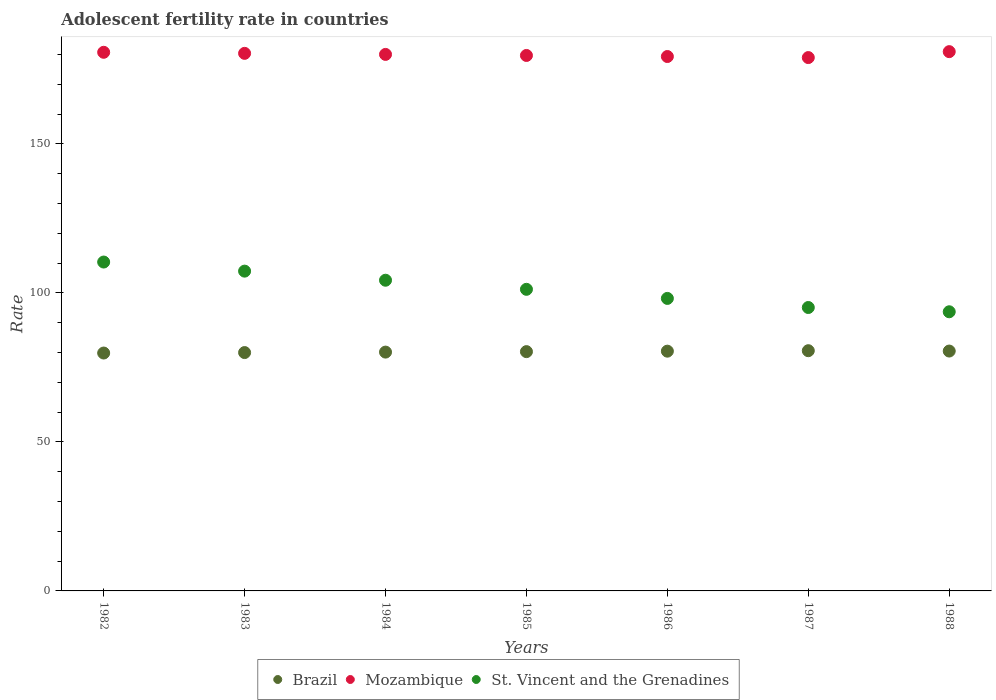How many different coloured dotlines are there?
Offer a terse response. 3. Is the number of dotlines equal to the number of legend labels?
Provide a succinct answer. Yes. What is the adolescent fertility rate in Brazil in 1987?
Your response must be concise. 80.61. Across all years, what is the maximum adolescent fertility rate in Mozambique?
Your answer should be very brief. 180.97. Across all years, what is the minimum adolescent fertility rate in Mozambique?
Your answer should be compact. 178.98. In which year was the adolescent fertility rate in Mozambique maximum?
Ensure brevity in your answer.  1988. What is the total adolescent fertility rate in St. Vincent and the Grenadines in the graph?
Ensure brevity in your answer.  710.1. What is the difference between the adolescent fertility rate in Brazil in 1984 and that in 1987?
Your answer should be compact. -0.47. What is the difference between the adolescent fertility rate in St. Vincent and the Grenadines in 1983 and the adolescent fertility rate in Mozambique in 1982?
Your answer should be compact. -73.44. What is the average adolescent fertility rate in St. Vincent and the Grenadines per year?
Ensure brevity in your answer.  101.44. In the year 1982, what is the difference between the adolescent fertility rate in Mozambique and adolescent fertility rate in Brazil?
Make the answer very short. 100.92. What is the ratio of the adolescent fertility rate in Brazil in 1984 to that in 1988?
Your response must be concise. 1. Is the adolescent fertility rate in St. Vincent and the Grenadines in 1982 less than that in 1987?
Offer a very short reply. No. What is the difference between the highest and the second highest adolescent fertility rate in Brazil?
Your response must be concise. 0.12. What is the difference between the highest and the lowest adolescent fertility rate in St. Vincent and the Grenadines?
Provide a short and direct response. 16.69. In how many years, is the adolescent fertility rate in Brazil greater than the average adolescent fertility rate in Brazil taken over all years?
Offer a terse response. 4. Is it the case that in every year, the sum of the adolescent fertility rate in Brazil and adolescent fertility rate in Mozambique  is greater than the adolescent fertility rate in St. Vincent and the Grenadines?
Provide a succinct answer. Yes. Does the adolescent fertility rate in Mozambique monotonically increase over the years?
Provide a short and direct response. No. Is the adolescent fertility rate in Mozambique strictly less than the adolescent fertility rate in Brazil over the years?
Provide a short and direct response. No. Does the graph contain grids?
Keep it short and to the point. No. How many legend labels are there?
Offer a very short reply. 3. How are the legend labels stacked?
Give a very brief answer. Horizontal. What is the title of the graph?
Provide a short and direct response. Adolescent fertility rate in countries. Does "Maldives" appear as one of the legend labels in the graph?
Ensure brevity in your answer.  No. What is the label or title of the X-axis?
Your answer should be very brief. Years. What is the label or title of the Y-axis?
Your response must be concise. Rate. What is the Rate of Brazil in 1982?
Make the answer very short. 79.83. What is the Rate of Mozambique in 1982?
Keep it short and to the point. 180.75. What is the Rate in St. Vincent and the Grenadines in 1982?
Your response must be concise. 110.36. What is the Rate of Brazil in 1983?
Your answer should be very brief. 79.99. What is the Rate in Mozambique in 1983?
Provide a succinct answer. 180.4. What is the Rate of St. Vincent and the Grenadines in 1983?
Provide a succinct answer. 107.31. What is the Rate in Brazil in 1984?
Keep it short and to the point. 80.14. What is the Rate of Mozambique in 1984?
Ensure brevity in your answer.  180.04. What is the Rate in St. Vincent and the Grenadines in 1984?
Your response must be concise. 104.26. What is the Rate in Brazil in 1985?
Give a very brief answer. 80.3. What is the Rate of Mozambique in 1985?
Give a very brief answer. 179.69. What is the Rate of St. Vincent and the Grenadines in 1985?
Your answer should be compact. 101.21. What is the Rate of Brazil in 1986?
Keep it short and to the point. 80.46. What is the Rate in Mozambique in 1986?
Offer a very short reply. 179.33. What is the Rate of St. Vincent and the Grenadines in 1986?
Provide a short and direct response. 98.16. What is the Rate in Brazil in 1987?
Keep it short and to the point. 80.61. What is the Rate of Mozambique in 1987?
Provide a succinct answer. 178.98. What is the Rate of St. Vincent and the Grenadines in 1987?
Provide a short and direct response. 95.11. What is the Rate of Brazil in 1988?
Your response must be concise. 80.5. What is the Rate in Mozambique in 1988?
Offer a terse response. 180.97. What is the Rate of St. Vincent and the Grenadines in 1988?
Keep it short and to the point. 93.68. Across all years, what is the maximum Rate in Brazil?
Provide a short and direct response. 80.61. Across all years, what is the maximum Rate in Mozambique?
Offer a terse response. 180.97. Across all years, what is the maximum Rate in St. Vincent and the Grenadines?
Ensure brevity in your answer.  110.36. Across all years, what is the minimum Rate in Brazil?
Your answer should be very brief. 79.83. Across all years, what is the minimum Rate of Mozambique?
Make the answer very short. 178.98. Across all years, what is the minimum Rate of St. Vincent and the Grenadines?
Make the answer very short. 93.68. What is the total Rate of Brazil in the graph?
Provide a short and direct response. 561.82. What is the total Rate in Mozambique in the graph?
Provide a short and direct response. 1260.16. What is the total Rate of St. Vincent and the Grenadines in the graph?
Provide a short and direct response. 710.1. What is the difference between the Rate in Brazil in 1982 and that in 1983?
Keep it short and to the point. -0.16. What is the difference between the Rate of Mozambique in 1982 and that in 1983?
Your response must be concise. 0.35. What is the difference between the Rate of St. Vincent and the Grenadines in 1982 and that in 1983?
Your answer should be very brief. 3.05. What is the difference between the Rate in Brazil in 1982 and that in 1984?
Offer a very short reply. -0.31. What is the difference between the Rate of Mozambique in 1982 and that in 1984?
Make the answer very short. 0.71. What is the difference between the Rate in St. Vincent and the Grenadines in 1982 and that in 1984?
Your answer should be compact. 6.1. What is the difference between the Rate in Brazil in 1982 and that in 1985?
Your response must be concise. -0.47. What is the difference between the Rate of Mozambique in 1982 and that in 1985?
Provide a succinct answer. 1.06. What is the difference between the Rate of St. Vincent and the Grenadines in 1982 and that in 1985?
Keep it short and to the point. 9.15. What is the difference between the Rate in Brazil in 1982 and that in 1986?
Give a very brief answer. -0.63. What is the difference between the Rate of Mozambique in 1982 and that in 1986?
Your response must be concise. 1.42. What is the difference between the Rate of St. Vincent and the Grenadines in 1982 and that in 1986?
Your answer should be compact. 12.21. What is the difference between the Rate of Brazil in 1982 and that in 1987?
Keep it short and to the point. -0.78. What is the difference between the Rate of Mozambique in 1982 and that in 1987?
Give a very brief answer. 1.77. What is the difference between the Rate of St. Vincent and the Grenadines in 1982 and that in 1987?
Your answer should be compact. 15.26. What is the difference between the Rate in Brazil in 1982 and that in 1988?
Provide a short and direct response. -0.67. What is the difference between the Rate of Mozambique in 1982 and that in 1988?
Offer a terse response. -0.22. What is the difference between the Rate of St. Vincent and the Grenadines in 1982 and that in 1988?
Offer a very short reply. 16.69. What is the difference between the Rate in Brazil in 1983 and that in 1984?
Make the answer very short. -0.16. What is the difference between the Rate in Mozambique in 1983 and that in 1984?
Provide a short and direct response. 0.35. What is the difference between the Rate of St. Vincent and the Grenadines in 1983 and that in 1984?
Give a very brief answer. 3.05. What is the difference between the Rate of Brazil in 1983 and that in 1985?
Your response must be concise. -0.31. What is the difference between the Rate of Mozambique in 1983 and that in 1985?
Ensure brevity in your answer.  0.71. What is the difference between the Rate in St. Vincent and the Grenadines in 1983 and that in 1985?
Your answer should be compact. 6.1. What is the difference between the Rate in Brazil in 1983 and that in 1986?
Ensure brevity in your answer.  -0.47. What is the difference between the Rate of Mozambique in 1983 and that in 1986?
Offer a very short reply. 1.06. What is the difference between the Rate in St. Vincent and the Grenadines in 1983 and that in 1986?
Ensure brevity in your answer.  9.15. What is the difference between the Rate of Brazil in 1983 and that in 1987?
Your response must be concise. -0.63. What is the difference between the Rate of Mozambique in 1983 and that in 1987?
Give a very brief answer. 1.42. What is the difference between the Rate in St. Vincent and the Grenadines in 1983 and that in 1987?
Offer a terse response. 12.21. What is the difference between the Rate in Brazil in 1983 and that in 1988?
Make the answer very short. -0.51. What is the difference between the Rate of Mozambique in 1983 and that in 1988?
Make the answer very short. -0.57. What is the difference between the Rate of St. Vincent and the Grenadines in 1983 and that in 1988?
Give a very brief answer. 13.64. What is the difference between the Rate of Brazil in 1984 and that in 1985?
Your response must be concise. -0.16. What is the difference between the Rate of Mozambique in 1984 and that in 1985?
Make the answer very short. 0.35. What is the difference between the Rate of St. Vincent and the Grenadines in 1984 and that in 1985?
Provide a succinct answer. 3.05. What is the difference between the Rate in Brazil in 1984 and that in 1986?
Keep it short and to the point. -0.31. What is the difference between the Rate of Mozambique in 1984 and that in 1986?
Make the answer very short. 0.71. What is the difference between the Rate of St. Vincent and the Grenadines in 1984 and that in 1986?
Your answer should be very brief. 6.1. What is the difference between the Rate in Brazil in 1984 and that in 1987?
Your answer should be very brief. -0.47. What is the difference between the Rate of Mozambique in 1984 and that in 1987?
Provide a short and direct response. 1.06. What is the difference between the Rate in St. Vincent and the Grenadines in 1984 and that in 1987?
Provide a succinct answer. 9.15. What is the difference between the Rate of Brazil in 1984 and that in 1988?
Your response must be concise. -0.35. What is the difference between the Rate in Mozambique in 1984 and that in 1988?
Offer a very short reply. -0.93. What is the difference between the Rate in St. Vincent and the Grenadines in 1984 and that in 1988?
Offer a terse response. 10.59. What is the difference between the Rate of Brazil in 1985 and that in 1986?
Offer a terse response. -0.16. What is the difference between the Rate of Mozambique in 1985 and that in 1986?
Provide a succinct answer. 0.35. What is the difference between the Rate of St. Vincent and the Grenadines in 1985 and that in 1986?
Provide a short and direct response. 3.05. What is the difference between the Rate of Brazil in 1985 and that in 1987?
Offer a very short reply. -0.31. What is the difference between the Rate in Mozambique in 1985 and that in 1987?
Your answer should be compact. 0.71. What is the difference between the Rate of St. Vincent and the Grenadines in 1985 and that in 1987?
Provide a succinct answer. 6.1. What is the difference between the Rate of Brazil in 1985 and that in 1988?
Ensure brevity in your answer.  -0.2. What is the difference between the Rate in Mozambique in 1985 and that in 1988?
Give a very brief answer. -1.28. What is the difference between the Rate in St. Vincent and the Grenadines in 1985 and that in 1988?
Your response must be concise. 7.53. What is the difference between the Rate of Brazil in 1986 and that in 1987?
Your answer should be very brief. -0.16. What is the difference between the Rate of Mozambique in 1986 and that in 1987?
Make the answer very short. 0.35. What is the difference between the Rate in St. Vincent and the Grenadines in 1986 and that in 1987?
Offer a very short reply. 3.05. What is the difference between the Rate in Brazil in 1986 and that in 1988?
Provide a short and direct response. -0.04. What is the difference between the Rate of Mozambique in 1986 and that in 1988?
Your answer should be compact. -1.64. What is the difference between the Rate in St. Vincent and the Grenadines in 1986 and that in 1988?
Offer a terse response. 4.48. What is the difference between the Rate in Brazil in 1987 and that in 1988?
Your answer should be very brief. 0.12. What is the difference between the Rate in Mozambique in 1987 and that in 1988?
Make the answer very short. -1.99. What is the difference between the Rate of St. Vincent and the Grenadines in 1987 and that in 1988?
Make the answer very short. 1.43. What is the difference between the Rate of Brazil in 1982 and the Rate of Mozambique in 1983?
Your answer should be very brief. -100.57. What is the difference between the Rate in Brazil in 1982 and the Rate in St. Vincent and the Grenadines in 1983?
Your response must be concise. -27.48. What is the difference between the Rate of Mozambique in 1982 and the Rate of St. Vincent and the Grenadines in 1983?
Your answer should be very brief. 73.44. What is the difference between the Rate of Brazil in 1982 and the Rate of Mozambique in 1984?
Provide a succinct answer. -100.21. What is the difference between the Rate in Brazil in 1982 and the Rate in St. Vincent and the Grenadines in 1984?
Keep it short and to the point. -24.43. What is the difference between the Rate of Mozambique in 1982 and the Rate of St. Vincent and the Grenadines in 1984?
Give a very brief answer. 76.49. What is the difference between the Rate of Brazil in 1982 and the Rate of Mozambique in 1985?
Your response must be concise. -99.86. What is the difference between the Rate of Brazil in 1982 and the Rate of St. Vincent and the Grenadines in 1985?
Provide a succinct answer. -21.38. What is the difference between the Rate in Mozambique in 1982 and the Rate in St. Vincent and the Grenadines in 1985?
Your answer should be very brief. 79.54. What is the difference between the Rate of Brazil in 1982 and the Rate of Mozambique in 1986?
Offer a terse response. -99.5. What is the difference between the Rate in Brazil in 1982 and the Rate in St. Vincent and the Grenadines in 1986?
Keep it short and to the point. -18.33. What is the difference between the Rate of Mozambique in 1982 and the Rate of St. Vincent and the Grenadines in 1986?
Offer a very short reply. 82.59. What is the difference between the Rate of Brazil in 1982 and the Rate of Mozambique in 1987?
Provide a succinct answer. -99.15. What is the difference between the Rate in Brazil in 1982 and the Rate in St. Vincent and the Grenadines in 1987?
Provide a short and direct response. -15.28. What is the difference between the Rate in Mozambique in 1982 and the Rate in St. Vincent and the Grenadines in 1987?
Provide a short and direct response. 85.64. What is the difference between the Rate in Brazil in 1982 and the Rate in Mozambique in 1988?
Your response must be concise. -101.14. What is the difference between the Rate in Brazil in 1982 and the Rate in St. Vincent and the Grenadines in 1988?
Give a very brief answer. -13.85. What is the difference between the Rate of Mozambique in 1982 and the Rate of St. Vincent and the Grenadines in 1988?
Your response must be concise. 87.07. What is the difference between the Rate of Brazil in 1983 and the Rate of Mozambique in 1984?
Your answer should be compact. -100.06. What is the difference between the Rate of Brazil in 1983 and the Rate of St. Vincent and the Grenadines in 1984?
Offer a very short reply. -24.28. What is the difference between the Rate of Mozambique in 1983 and the Rate of St. Vincent and the Grenadines in 1984?
Give a very brief answer. 76.13. What is the difference between the Rate of Brazil in 1983 and the Rate of Mozambique in 1985?
Provide a succinct answer. -99.7. What is the difference between the Rate of Brazil in 1983 and the Rate of St. Vincent and the Grenadines in 1985?
Keep it short and to the point. -21.22. What is the difference between the Rate of Mozambique in 1983 and the Rate of St. Vincent and the Grenadines in 1985?
Keep it short and to the point. 79.19. What is the difference between the Rate of Brazil in 1983 and the Rate of Mozambique in 1986?
Provide a succinct answer. -99.35. What is the difference between the Rate of Brazil in 1983 and the Rate of St. Vincent and the Grenadines in 1986?
Your answer should be compact. -18.17. What is the difference between the Rate of Mozambique in 1983 and the Rate of St. Vincent and the Grenadines in 1986?
Provide a short and direct response. 82.24. What is the difference between the Rate of Brazil in 1983 and the Rate of Mozambique in 1987?
Your answer should be very brief. -98.99. What is the difference between the Rate of Brazil in 1983 and the Rate of St. Vincent and the Grenadines in 1987?
Your answer should be compact. -15.12. What is the difference between the Rate in Mozambique in 1983 and the Rate in St. Vincent and the Grenadines in 1987?
Your answer should be compact. 85.29. What is the difference between the Rate in Brazil in 1983 and the Rate in Mozambique in 1988?
Offer a very short reply. -100.98. What is the difference between the Rate in Brazil in 1983 and the Rate in St. Vincent and the Grenadines in 1988?
Provide a succinct answer. -13.69. What is the difference between the Rate of Mozambique in 1983 and the Rate of St. Vincent and the Grenadines in 1988?
Keep it short and to the point. 86.72. What is the difference between the Rate in Brazil in 1984 and the Rate in Mozambique in 1985?
Give a very brief answer. -99.55. What is the difference between the Rate of Brazil in 1984 and the Rate of St. Vincent and the Grenadines in 1985?
Keep it short and to the point. -21.07. What is the difference between the Rate of Mozambique in 1984 and the Rate of St. Vincent and the Grenadines in 1985?
Provide a short and direct response. 78.83. What is the difference between the Rate of Brazil in 1984 and the Rate of Mozambique in 1986?
Offer a terse response. -99.19. What is the difference between the Rate of Brazil in 1984 and the Rate of St. Vincent and the Grenadines in 1986?
Provide a short and direct response. -18.02. What is the difference between the Rate of Mozambique in 1984 and the Rate of St. Vincent and the Grenadines in 1986?
Offer a terse response. 81.88. What is the difference between the Rate in Brazil in 1984 and the Rate in Mozambique in 1987?
Make the answer very short. -98.84. What is the difference between the Rate in Brazil in 1984 and the Rate in St. Vincent and the Grenadines in 1987?
Provide a short and direct response. -14.97. What is the difference between the Rate of Mozambique in 1984 and the Rate of St. Vincent and the Grenadines in 1987?
Ensure brevity in your answer.  84.93. What is the difference between the Rate in Brazil in 1984 and the Rate in Mozambique in 1988?
Make the answer very short. -100.83. What is the difference between the Rate of Brazil in 1984 and the Rate of St. Vincent and the Grenadines in 1988?
Keep it short and to the point. -13.53. What is the difference between the Rate of Mozambique in 1984 and the Rate of St. Vincent and the Grenadines in 1988?
Make the answer very short. 86.37. What is the difference between the Rate in Brazil in 1985 and the Rate in Mozambique in 1986?
Offer a terse response. -99.03. What is the difference between the Rate in Brazil in 1985 and the Rate in St. Vincent and the Grenadines in 1986?
Give a very brief answer. -17.86. What is the difference between the Rate in Mozambique in 1985 and the Rate in St. Vincent and the Grenadines in 1986?
Keep it short and to the point. 81.53. What is the difference between the Rate of Brazil in 1985 and the Rate of Mozambique in 1987?
Keep it short and to the point. -98.68. What is the difference between the Rate of Brazil in 1985 and the Rate of St. Vincent and the Grenadines in 1987?
Keep it short and to the point. -14.81. What is the difference between the Rate in Mozambique in 1985 and the Rate in St. Vincent and the Grenadines in 1987?
Your response must be concise. 84.58. What is the difference between the Rate in Brazil in 1985 and the Rate in Mozambique in 1988?
Provide a succinct answer. -100.67. What is the difference between the Rate of Brazil in 1985 and the Rate of St. Vincent and the Grenadines in 1988?
Provide a short and direct response. -13.38. What is the difference between the Rate of Mozambique in 1985 and the Rate of St. Vincent and the Grenadines in 1988?
Offer a very short reply. 86.01. What is the difference between the Rate in Brazil in 1986 and the Rate in Mozambique in 1987?
Provide a succinct answer. -98.52. What is the difference between the Rate of Brazil in 1986 and the Rate of St. Vincent and the Grenadines in 1987?
Keep it short and to the point. -14.65. What is the difference between the Rate in Mozambique in 1986 and the Rate in St. Vincent and the Grenadines in 1987?
Offer a terse response. 84.23. What is the difference between the Rate in Brazil in 1986 and the Rate in Mozambique in 1988?
Keep it short and to the point. -100.51. What is the difference between the Rate of Brazil in 1986 and the Rate of St. Vincent and the Grenadines in 1988?
Your response must be concise. -13.22. What is the difference between the Rate of Mozambique in 1986 and the Rate of St. Vincent and the Grenadines in 1988?
Provide a short and direct response. 85.66. What is the difference between the Rate in Brazil in 1987 and the Rate in Mozambique in 1988?
Provide a succinct answer. -100.36. What is the difference between the Rate in Brazil in 1987 and the Rate in St. Vincent and the Grenadines in 1988?
Offer a very short reply. -13.06. What is the difference between the Rate in Mozambique in 1987 and the Rate in St. Vincent and the Grenadines in 1988?
Offer a terse response. 85.3. What is the average Rate of Brazil per year?
Give a very brief answer. 80.26. What is the average Rate of Mozambique per year?
Offer a very short reply. 180.02. What is the average Rate of St. Vincent and the Grenadines per year?
Your answer should be compact. 101.44. In the year 1982, what is the difference between the Rate of Brazil and Rate of Mozambique?
Provide a short and direct response. -100.92. In the year 1982, what is the difference between the Rate in Brazil and Rate in St. Vincent and the Grenadines?
Give a very brief answer. -30.54. In the year 1982, what is the difference between the Rate of Mozambique and Rate of St. Vincent and the Grenadines?
Give a very brief answer. 70.39. In the year 1983, what is the difference between the Rate in Brazil and Rate in Mozambique?
Offer a very short reply. -100.41. In the year 1983, what is the difference between the Rate in Brazil and Rate in St. Vincent and the Grenadines?
Offer a terse response. -27.33. In the year 1983, what is the difference between the Rate in Mozambique and Rate in St. Vincent and the Grenadines?
Make the answer very short. 73.08. In the year 1984, what is the difference between the Rate of Brazil and Rate of Mozambique?
Make the answer very short. -99.9. In the year 1984, what is the difference between the Rate of Brazil and Rate of St. Vincent and the Grenadines?
Offer a very short reply. -24.12. In the year 1984, what is the difference between the Rate in Mozambique and Rate in St. Vincent and the Grenadines?
Provide a short and direct response. 75.78. In the year 1985, what is the difference between the Rate in Brazil and Rate in Mozambique?
Offer a terse response. -99.39. In the year 1985, what is the difference between the Rate of Brazil and Rate of St. Vincent and the Grenadines?
Your answer should be very brief. -20.91. In the year 1985, what is the difference between the Rate in Mozambique and Rate in St. Vincent and the Grenadines?
Your response must be concise. 78.48. In the year 1986, what is the difference between the Rate of Brazil and Rate of Mozambique?
Your answer should be very brief. -98.88. In the year 1986, what is the difference between the Rate of Brazil and Rate of St. Vincent and the Grenadines?
Provide a succinct answer. -17.7. In the year 1986, what is the difference between the Rate in Mozambique and Rate in St. Vincent and the Grenadines?
Give a very brief answer. 81.17. In the year 1987, what is the difference between the Rate of Brazil and Rate of Mozambique?
Ensure brevity in your answer.  -98.37. In the year 1987, what is the difference between the Rate of Brazil and Rate of St. Vincent and the Grenadines?
Keep it short and to the point. -14.5. In the year 1987, what is the difference between the Rate in Mozambique and Rate in St. Vincent and the Grenadines?
Your answer should be compact. 83.87. In the year 1988, what is the difference between the Rate in Brazil and Rate in Mozambique?
Give a very brief answer. -100.47. In the year 1988, what is the difference between the Rate of Brazil and Rate of St. Vincent and the Grenadines?
Ensure brevity in your answer.  -13.18. In the year 1988, what is the difference between the Rate of Mozambique and Rate of St. Vincent and the Grenadines?
Give a very brief answer. 87.29. What is the ratio of the Rate in Brazil in 1982 to that in 1983?
Offer a very short reply. 1. What is the ratio of the Rate in Mozambique in 1982 to that in 1983?
Give a very brief answer. 1. What is the ratio of the Rate in St. Vincent and the Grenadines in 1982 to that in 1983?
Offer a very short reply. 1.03. What is the ratio of the Rate in Brazil in 1982 to that in 1984?
Offer a terse response. 1. What is the ratio of the Rate in St. Vincent and the Grenadines in 1982 to that in 1984?
Offer a terse response. 1.06. What is the ratio of the Rate of Mozambique in 1982 to that in 1985?
Provide a short and direct response. 1.01. What is the ratio of the Rate of St. Vincent and the Grenadines in 1982 to that in 1985?
Ensure brevity in your answer.  1.09. What is the ratio of the Rate of Mozambique in 1982 to that in 1986?
Your answer should be compact. 1.01. What is the ratio of the Rate in St. Vincent and the Grenadines in 1982 to that in 1986?
Keep it short and to the point. 1.12. What is the ratio of the Rate of Brazil in 1982 to that in 1987?
Your answer should be very brief. 0.99. What is the ratio of the Rate in Mozambique in 1982 to that in 1987?
Ensure brevity in your answer.  1.01. What is the ratio of the Rate of St. Vincent and the Grenadines in 1982 to that in 1987?
Your answer should be compact. 1.16. What is the ratio of the Rate in Brazil in 1982 to that in 1988?
Provide a succinct answer. 0.99. What is the ratio of the Rate of Mozambique in 1982 to that in 1988?
Your answer should be very brief. 1. What is the ratio of the Rate in St. Vincent and the Grenadines in 1982 to that in 1988?
Make the answer very short. 1.18. What is the ratio of the Rate of St. Vincent and the Grenadines in 1983 to that in 1984?
Offer a very short reply. 1.03. What is the ratio of the Rate in Brazil in 1983 to that in 1985?
Offer a very short reply. 1. What is the ratio of the Rate of St. Vincent and the Grenadines in 1983 to that in 1985?
Your answer should be compact. 1.06. What is the ratio of the Rate in Brazil in 1983 to that in 1986?
Ensure brevity in your answer.  0.99. What is the ratio of the Rate of Mozambique in 1983 to that in 1986?
Provide a short and direct response. 1.01. What is the ratio of the Rate of St. Vincent and the Grenadines in 1983 to that in 1986?
Give a very brief answer. 1.09. What is the ratio of the Rate in Brazil in 1983 to that in 1987?
Provide a succinct answer. 0.99. What is the ratio of the Rate in Mozambique in 1983 to that in 1987?
Give a very brief answer. 1.01. What is the ratio of the Rate in St. Vincent and the Grenadines in 1983 to that in 1987?
Provide a succinct answer. 1.13. What is the ratio of the Rate of Brazil in 1983 to that in 1988?
Offer a terse response. 0.99. What is the ratio of the Rate in St. Vincent and the Grenadines in 1983 to that in 1988?
Offer a terse response. 1.15. What is the ratio of the Rate of Mozambique in 1984 to that in 1985?
Offer a very short reply. 1. What is the ratio of the Rate in St. Vincent and the Grenadines in 1984 to that in 1985?
Your response must be concise. 1.03. What is the ratio of the Rate of Brazil in 1984 to that in 1986?
Ensure brevity in your answer.  1. What is the ratio of the Rate of Mozambique in 1984 to that in 1986?
Your response must be concise. 1. What is the ratio of the Rate of St. Vincent and the Grenadines in 1984 to that in 1986?
Your answer should be very brief. 1.06. What is the ratio of the Rate of Brazil in 1984 to that in 1987?
Ensure brevity in your answer.  0.99. What is the ratio of the Rate in Mozambique in 1984 to that in 1987?
Provide a short and direct response. 1.01. What is the ratio of the Rate of St. Vincent and the Grenadines in 1984 to that in 1987?
Ensure brevity in your answer.  1.1. What is the ratio of the Rate of Brazil in 1984 to that in 1988?
Give a very brief answer. 1. What is the ratio of the Rate in Mozambique in 1984 to that in 1988?
Provide a succinct answer. 0.99. What is the ratio of the Rate in St. Vincent and the Grenadines in 1984 to that in 1988?
Give a very brief answer. 1.11. What is the ratio of the Rate in St. Vincent and the Grenadines in 1985 to that in 1986?
Provide a short and direct response. 1.03. What is the ratio of the Rate in Mozambique in 1985 to that in 1987?
Ensure brevity in your answer.  1. What is the ratio of the Rate in St. Vincent and the Grenadines in 1985 to that in 1987?
Give a very brief answer. 1.06. What is the ratio of the Rate of Brazil in 1985 to that in 1988?
Offer a very short reply. 1. What is the ratio of the Rate of St. Vincent and the Grenadines in 1985 to that in 1988?
Provide a succinct answer. 1.08. What is the ratio of the Rate of Brazil in 1986 to that in 1987?
Your answer should be very brief. 1. What is the ratio of the Rate of St. Vincent and the Grenadines in 1986 to that in 1987?
Keep it short and to the point. 1.03. What is the ratio of the Rate in Brazil in 1986 to that in 1988?
Provide a succinct answer. 1. What is the ratio of the Rate of St. Vincent and the Grenadines in 1986 to that in 1988?
Provide a succinct answer. 1.05. What is the ratio of the Rate of St. Vincent and the Grenadines in 1987 to that in 1988?
Make the answer very short. 1.02. What is the difference between the highest and the second highest Rate of Brazil?
Keep it short and to the point. 0.12. What is the difference between the highest and the second highest Rate of Mozambique?
Provide a short and direct response. 0.22. What is the difference between the highest and the second highest Rate in St. Vincent and the Grenadines?
Offer a very short reply. 3.05. What is the difference between the highest and the lowest Rate in Brazil?
Your answer should be very brief. 0.78. What is the difference between the highest and the lowest Rate in Mozambique?
Your response must be concise. 1.99. What is the difference between the highest and the lowest Rate of St. Vincent and the Grenadines?
Offer a terse response. 16.69. 